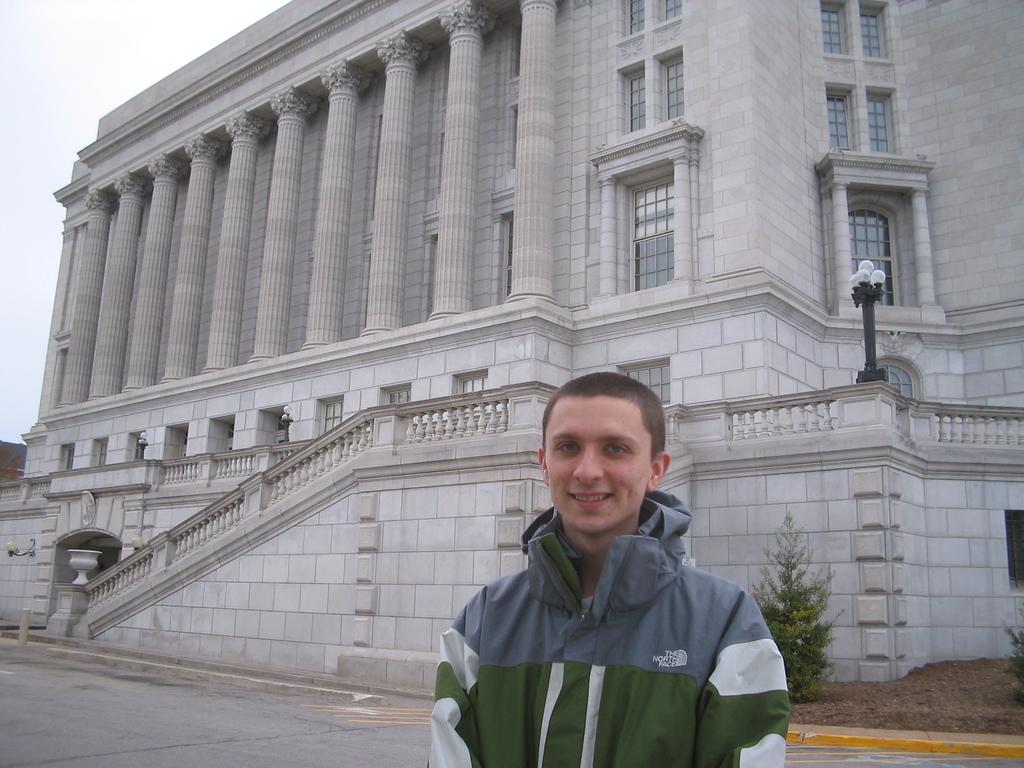What brand jacket is he wearing?
Offer a very short reply. The north face. What color is the brand on his jacket?
Give a very brief answer. White. 